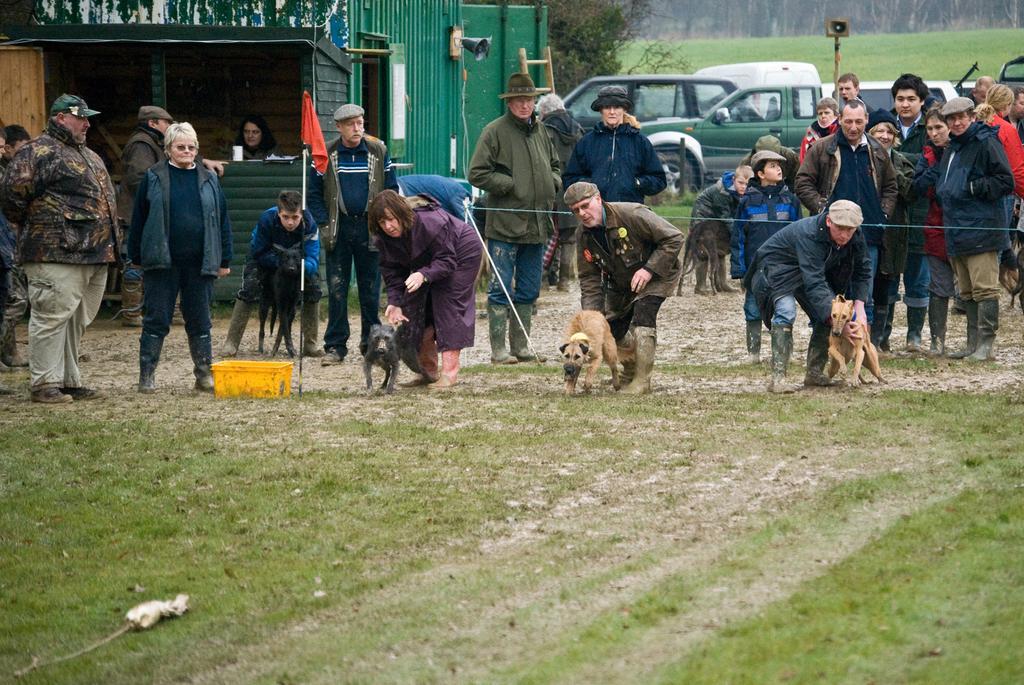Please provide a concise description of this image. In this picture we can see a many group of people are standing. Here three members are holding the dogs. There are three dogs. Backside there are group of people watching the dogs. To the left side there is a stole. Inside that stole there is a woman sitting in it. And we can see a ladder to the stole. And back side there is a tree. And there are some cars around they are of green color. We can also see a flagpole and flag is in red color. 